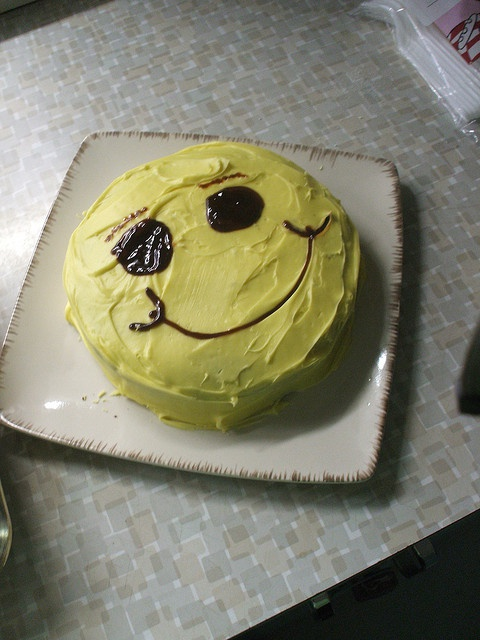Describe the objects in this image and their specific colors. I can see a cake in black, olive, and khaki tones in this image. 